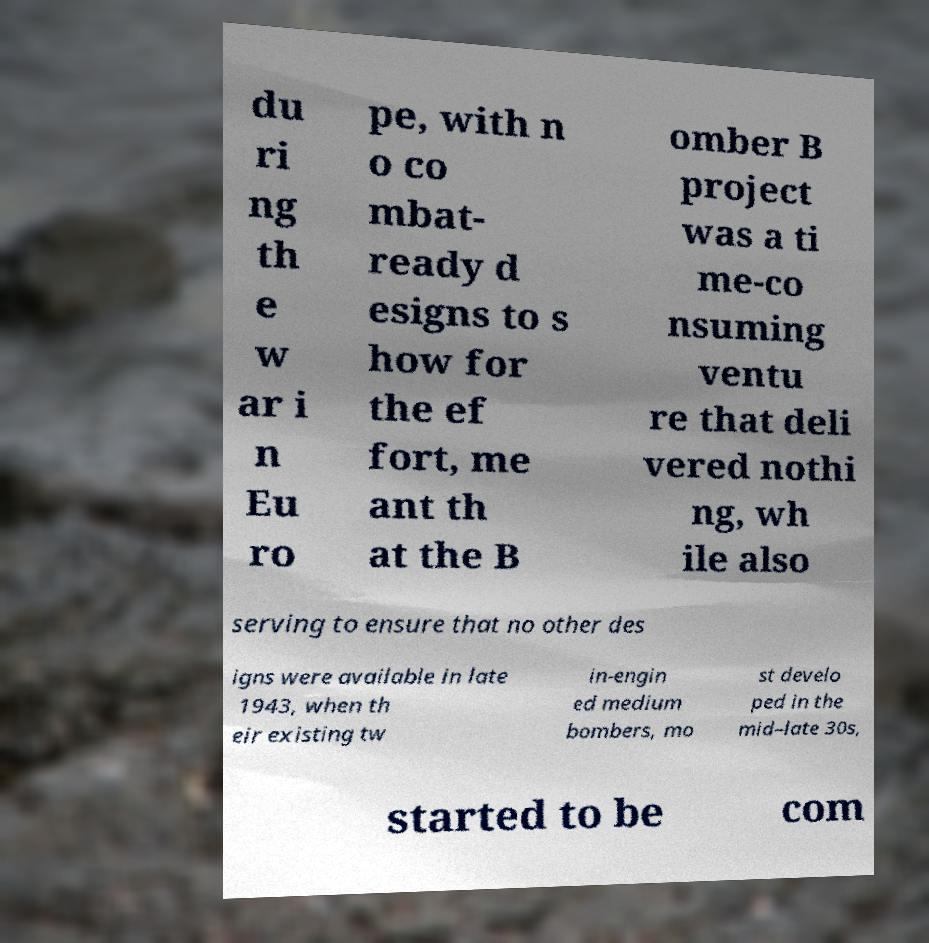Please identify and transcribe the text found in this image. du ri ng th e w ar i n Eu ro pe, with n o co mbat- ready d esigns to s how for the ef fort, me ant th at the B omber B project was a ti me-co nsuming ventu re that deli vered nothi ng, wh ile also serving to ensure that no other des igns were available in late 1943, when th eir existing tw in-engin ed medium bombers, mo st develo ped in the mid–late 30s, started to be com 